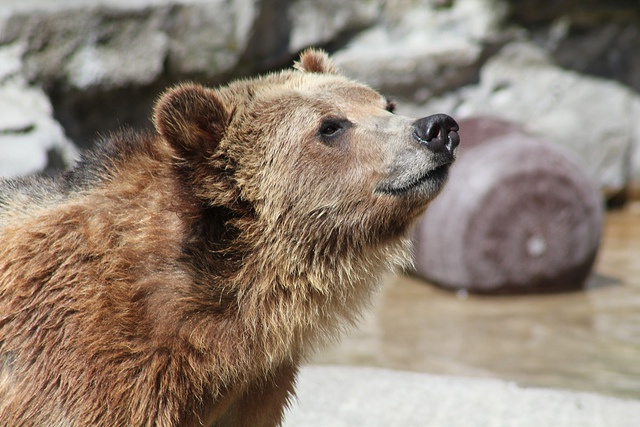Describe the objects in this image and their specific colors. I can see a bear in lightgray, gray, tan, maroon, and black tones in this image. 